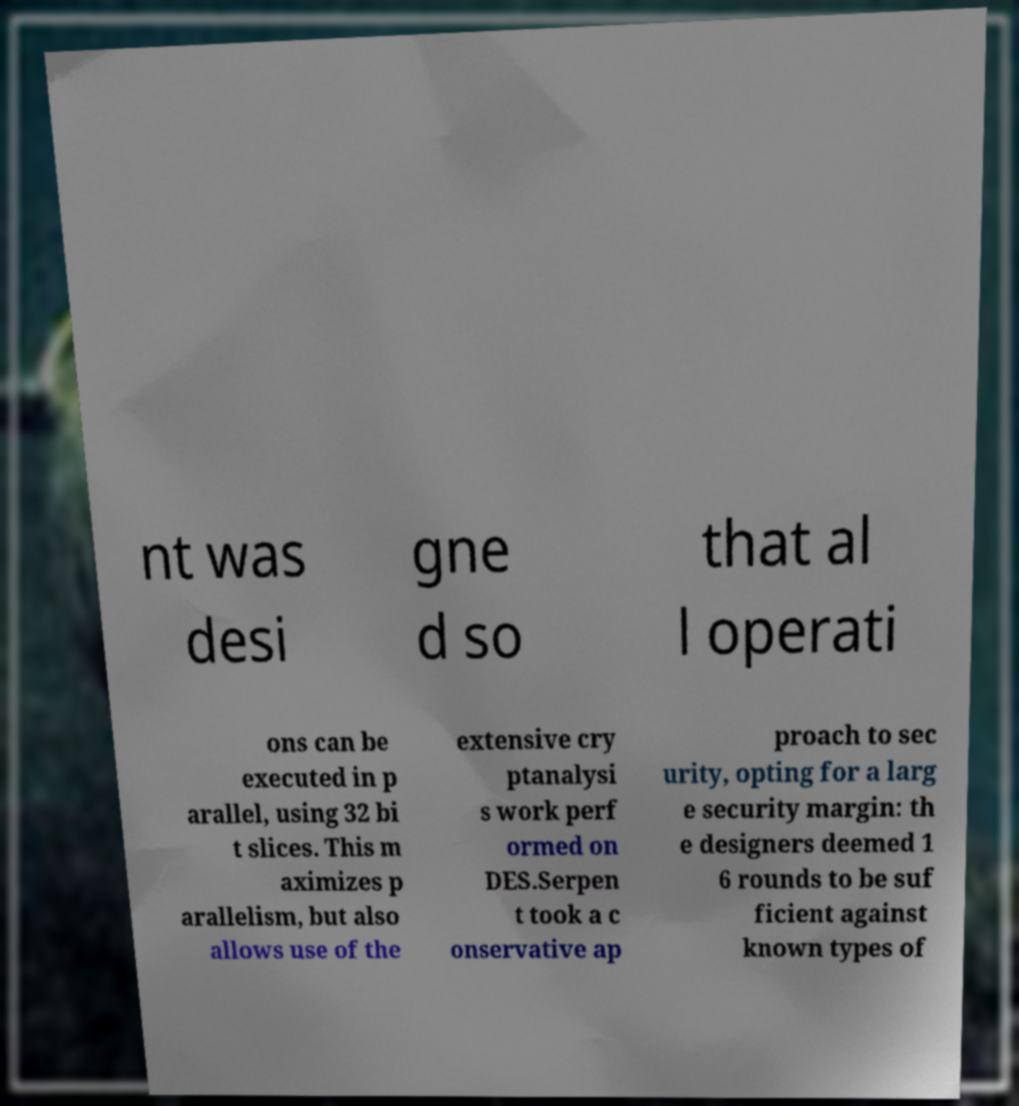What messages or text are displayed in this image? I need them in a readable, typed format. nt was desi gne d so that al l operati ons can be executed in p arallel, using 32 bi t slices. This m aximizes p arallelism, but also allows use of the extensive cry ptanalysi s work perf ormed on DES.Serpen t took a c onservative ap proach to sec urity, opting for a larg e security margin: th e designers deemed 1 6 rounds to be suf ficient against known types of 